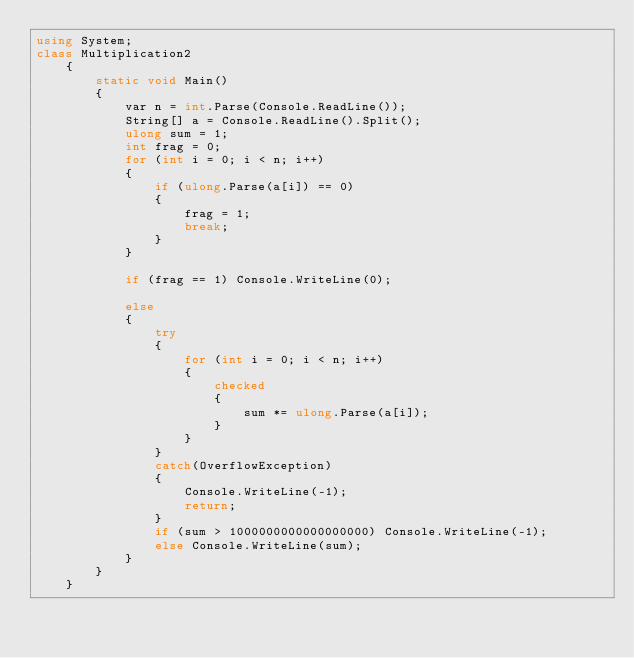<code> <loc_0><loc_0><loc_500><loc_500><_C#_>using System;
class Multiplication2
    {
        static void Main()
        {
            var n = int.Parse(Console.ReadLine());
            String[] a = Console.ReadLine().Split();
            ulong sum = 1;
            int frag = 0;
            for (int i = 0; i < n; i++)
            {
                if (ulong.Parse(a[i]) == 0)
                {
                    frag = 1;
                    break;
                }
            }

            if (frag == 1) Console.WriteLine(0);

            else
            {
                try
                {
                    for (int i = 0; i < n; i++)
                    {
                        checked
                        {
                            sum *= ulong.Parse(a[i]);
                        }
                    }
                }
                catch(OverflowException)
                {
                    Console.WriteLine(-1);
                    return;
                }
                if (sum > 1000000000000000000) Console.WriteLine(-1);
                else Console.WriteLine(sum);
            }
        }
    }</code> 